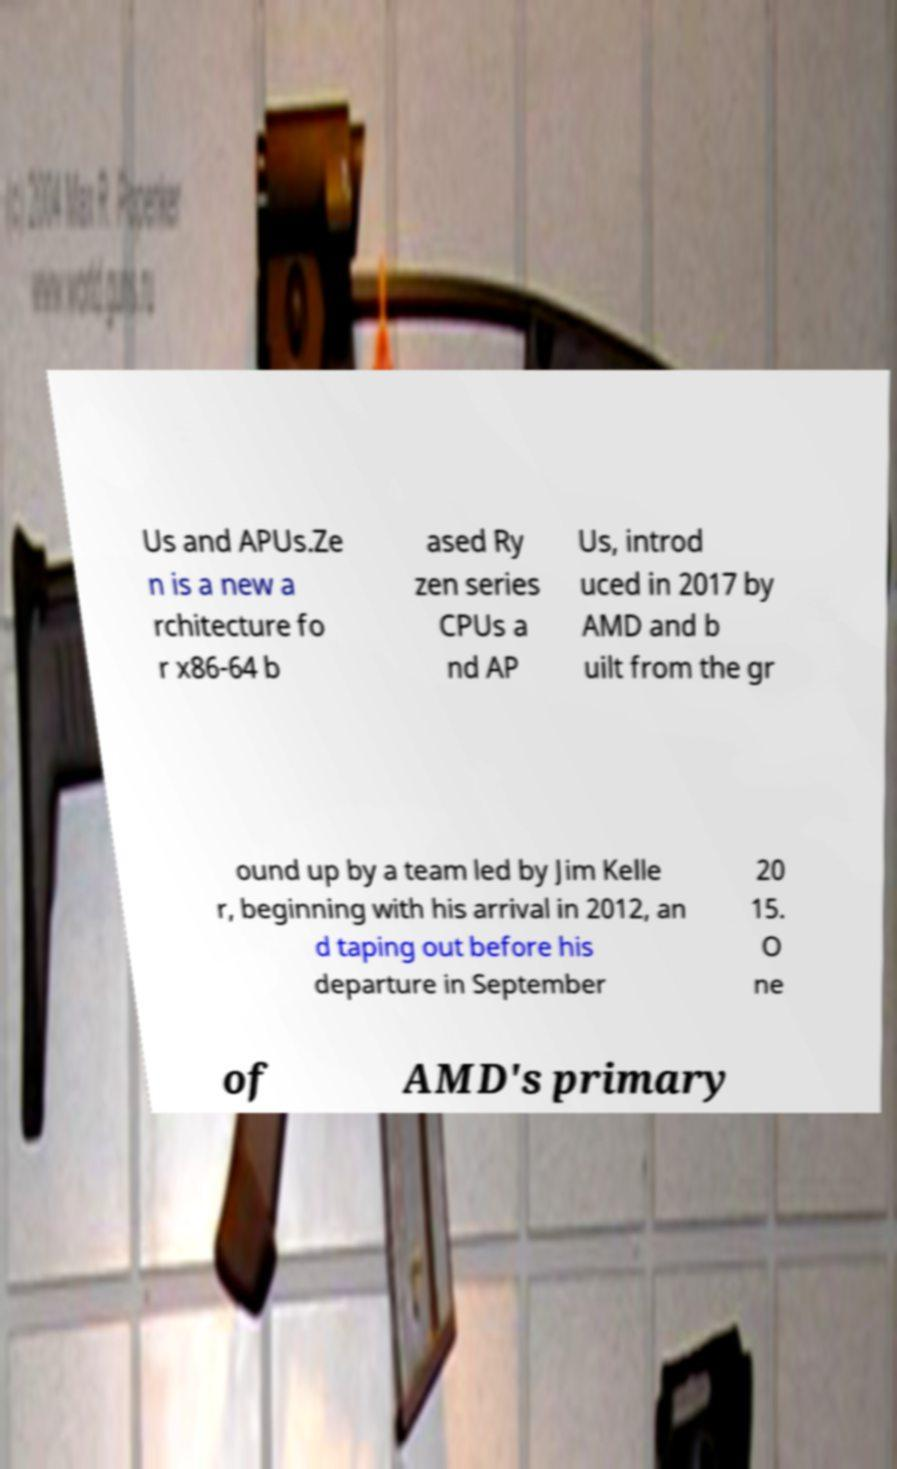Can you accurately transcribe the text from the provided image for me? Us and APUs.Ze n is a new a rchitecture fo r x86-64 b ased Ry zen series CPUs a nd AP Us, introd uced in 2017 by AMD and b uilt from the gr ound up by a team led by Jim Kelle r, beginning with his arrival in 2012, an d taping out before his departure in September 20 15. O ne of AMD's primary 